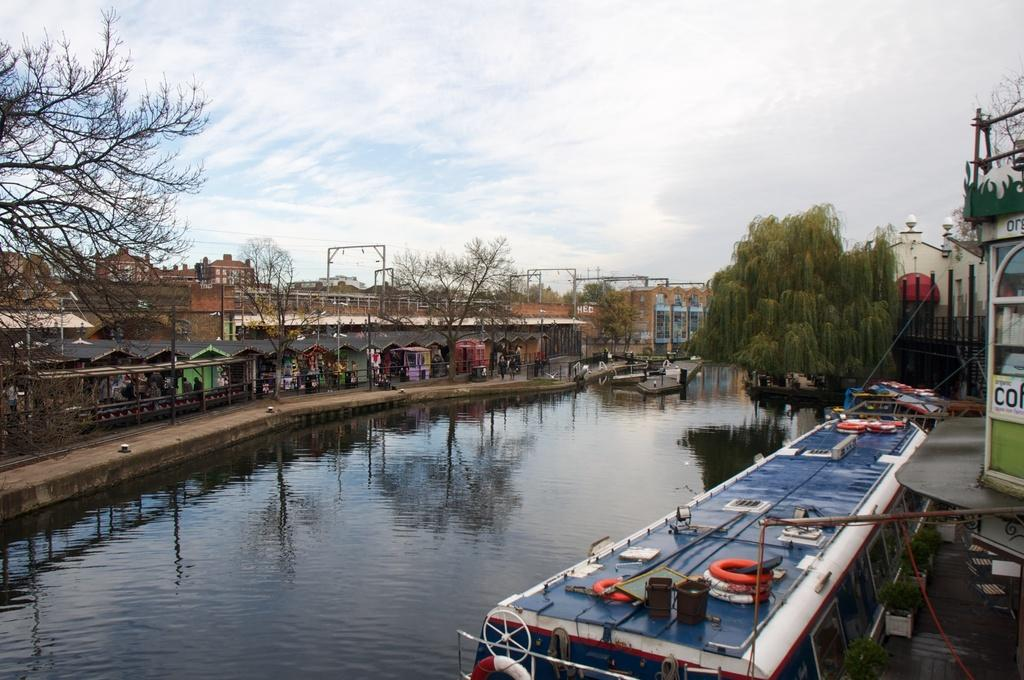What type of body of water is present in the image? There is a lake in the picture. What can be seen floating on the lake? There are boats in the picture. What structures are visible in the image? There are buildings in the picture. What type of vegetation is present in the image? There are trees in the picture. What is the condition of the sky in the image? The sky is clear in the picture. Can you see a throne in the image? There is no throne present in the image. 